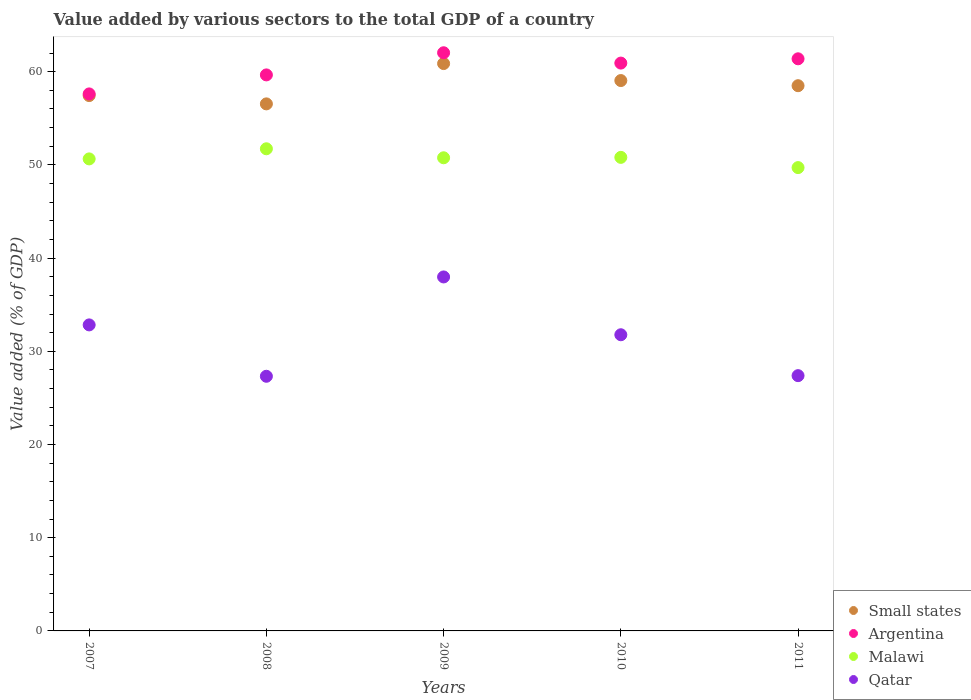How many different coloured dotlines are there?
Your answer should be compact. 4. What is the value added by various sectors to the total GDP in Qatar in 2010?
Ensure brevity in your answer.  31.78. Across all years, what is the maximum value added by various sectors to the total GDP in Argentina?
Your response must be concise. 62.03. Across all years, what is the minimum value added by various sectors to the total GDP in Argentina?
Provide a short and direct response. 57.61. In which year was the value added by various sectors to the total GDP in Malawi minimum?
Your answer should be compact. 2011. What is the total value added by various sectors to the total GDP in Argentina in the graph?
Keep it short and to the point. 301.6. What is the difference between the value added by various sectors to the total GDP in Malawi in 2009 and that in 2010?
Your answer should be compact. -0.04. What is the difference between the value added by various sectors to the total GDP in Qatar in 2011 and the value added by various sectors to the total GDP in Malawi in 2010?
Offer a very short reply. -23.42. What is the average value added by various sectors to the total GDP in Small states per year?
Keep it short and to the point. 58.48. In the year 2007, what is the difference between the value added by various sectors to the total GDP in Argentina and value added by various sectors to the total GDP in Small states?
Offer a very short reply. 0.18. In how many years, is the value added by various sectors to the total GDP in Qatar greater than 58 %?
Ensure brevity in your answer.  0. What is the ratio of the value added by various sectors to the total GDP in Malawi in 2007 to that in 2009?
Offer a terse response. 1. Is the difference between the value added by various sectors to the total GDP in Argentina in 2010 and 2011 greater than the difference between the value added by various sectors to the total GDP in Small states in 2010 and 2011?
Your answer should be very brief. No. What is the difference between the highest and the second highest value added by various sectors to the total GDP in Small states?
Keep it short and to the point. 1.82. What is the difference between the highest and the lowest value added by various sectors to the total GDP in Qatar?
Provide a succinct answer. 10.66. Is the sum of the value added by various sectors to the total GDP in Malawi in 2008 and 2010 greater than the maximum value added by various sectors to the total GDP in Argentina across all years?
Make the answer very short. Yes. Is the value added by various sectors to the total GDP in Malawi strictly greater than the value added by various sectors to the total GDP in Qatar over the years?
Ensure brevity in your answer.  Yes. How many years are there in the graph?
Your response must be concise. 5. What is the difference between two consecutive major ticks on the Y-axis?
Make the answer very short. 10. Does the graph contain any zero values?
Your response must be concise. No. Where does the legend appear in the graph?
Ensure brevity in your answer.  Bottom right. How are the legend labels stacked?
Ensure brevity in your answer.  Vertical. What is the title of the graph?
Your response must be concise. Value added by various sectors to the total GDP of a country. Does "Equatorial Guinea" appear as one of the legend labels in the graph?
Provide a short and direct response. No. What is the label or title of the X-axis?
Your response must be concise. Years. What is the label or title of the Y-axis?
Offer a very short reply. Value added (% of GDP). What is the Value added (% of GDP) in Small states in 2007?
Your answer should be compact. 57.43. What is the Value added (% of GDP) of Argentina in 2007?
Ensure brevity in your answer.  57.61. What is the Value added (% of GDP) in Malawi in 2007?
Keep it short and to the point. 50.64. What is the Value added (% of GDP) of Qatar in 2007?
Provide a succinct answer. 32.83. What is the Value added (% of GDP) of Small states in 2008?
Provide a succinct answer. 56.54. What is the Value added (% of GDP) of Argentina in 2008?
Keep it short and to the point. 59.65. What is the Value added (% of GDP) in Malawi in 2008?
Offer a very short reply. 51.73. What is the Value added (% of GDP) in Qatar in 2008?
Offer a terse response. 27.32. What is the Value added (% of GDP) in Small states in 2009?
Ensure brevity in your answer.  60.87. What is the Value added (% of GDP) of Argentina in 2009?
Give a very brief answer. 62.03. What is the Value added (% of GDP) in Malawi in 2009?
Offer a very short reply. 50.76. What is the Value added (% of GDP) of Qatar in 2009?
Provide a short and direct response. 37.98. What is the Value added (% of GDP) in Small states in 2010?
Make the answer very short. 59.05. What is the Value added (% of GDP) of Argentina in 2010?
Your response must be concise. 60.92. What is the Value added (% of GDP) of Malawi in 2010?
Give a very brief answer. 50.81. What is the Value added (% of GDP) of Qatar in 2010?
Make the answer very short. 31.78. What is the Value added (% of GDP) of Small states in 2011?
Your answer should be compact. 58.49. What is the Value added (% of GDP) in Argentina in 2011?
Make the answer very short. 61.38. What is the Value added (% of GDP) of Malawi in 2011?
Give a very brief answer. 49.71. What is the Value added (% of GDP) of Qatar in 2011?
Your answer should be compact. 27.39. Across all years, what is the maximum Value added (% of GDP) in Small states?
Give a very brief answer. 60.87. Across all years, what is the maximum Value added (% of GDP) of Argentina?
Offer a very short reply. 62.03. Across all years, what is the maximum Value added (% of GDP) of Malawi?
Make the answer very short. 51.73. Across all years, what is the maximum Value added (% of GDP) of Qatar?
Offer a very short reply. 37.98. Across all years, what is the minimum Value added (% of GDP) of Small states?
Give a very brief answer. 56.54. Across all years, what is the minimum Value added (% of GDP) in Argentina?
Your response must be concise. 57.61. Across all years, what is the minimum Value added (% of GDP) in Malawi?
Provide a short and direct response. 49.71. Across all years, what is the minimum Value added (% of GDP) of Qatar?
Your answer should be compact. 27.32. What is the total Value added (% of GDP) in Small states in the graph?
Keep it short and to the point. 292.39. What is the total Value added (% of GDP) of Argentina in the graph?
Make the answer very short. 301.6. What is the total Value added (% of GDP) of Malawi in the graph?
Ensure brevity in your answer.  253.64. What is the total Value added (% of GDP) of Qatar in the graph?
Provide a short and direct response. 157.29. What is the difference between the Value added (% of GDP) of Small states in 2007 and that in 2008?
Make the answer very short. 0.89. What is the difference between the Value added (% of GDP) in Argentina in 2007 and that in 2008?
Make the answer very short. -2.04. What is the difference between the Value added (% of GDP) in Malawi in 2007 and that in 2008?
Your response must be concise. -1.09. What is the difference between the Value added (% of GDP) in Qatar in 2007 and that in 2008?
Offer a terse response. 5.51. What is the difference between the Value added (% of GDP) in Small states in 2007 and that in 2009?
Keep it short and to the point. -3.44. What is the difference between the Value added (% of GDP) in Argentina in 2007 and that in 2009?
Your answer should be compact. -4.42. What is the difference between the Value added (% of GDP) of Malawi in 2007 and that in 2009?
Your answer should be very brief. -0.12. What is the difference between the Value added (% of GDP) of Qatar in 2007 and that in 2009?
Give a very brief answer. -5.14. What is the difference between the Value added (% of GDP) in Small states in 2007 and that in 2010?
Ensure brevity in your answer.  -1.61. What is the difference between the Value added (% of GDP) of Argentina in 2007 and that in 2010?
Provide a short and direct response. -3.31. What is the difference between the Value added (% of GDP) of Malawi in 2007 and that in 2010?
Make the answer very short. -0.16. What is the difference between the Value added (% of GDP) of Qatar in 2007 and that in 2010?
Provide a succinct answer. 1.06. What is the difference between the Value added (% of GDP) in Small states in 2007 and that in 2011?
Keep it short and to the point. -1.06. What is the difference between the Value added (% of GDP) of Argentina in 2007 and that in 2011?
Keep it short and to the point. -3.77. What is the difference between the Value added (% of GDP) in Malawi in 2007 and that in 2011?
Your answer should be very brief. 0.93. What is the difference between the Value added (% of GDP) in Qatar in 2007 and that in 2011?
Provide a succinct answer. 5.45. What is the difference between the Value added (% of GDP) of Small states in 2008 and that in 2009?
Make the answer very short. -4.33. What is the difference between the Value added (% of GDP) in Argentina in 2008 and that in 2009?
Your response must be concise. -2.38. What is the difference between the Value added (% of GDP) in Malawi in 2008 and that in 2009?
Ensure brevity in your answer.  0.97. What is the difference between the Value added (% of GDP) of Qatar in 2008 and that in 2009?
Make the answer very short. -10.66. What is the difference between the Value added (% of GDP) of Small states in 2008 and that in 2010?
Offer a terse response. -2.5. What is the difference between the Value added (% of GDP) of Argentina in 2008 and that in 2010?
Provide a short and direct response. -1.27. What is the difference between the Value added (% of GDP) in Malawi in 2008 and that in 2010?
Your answer should be very brief. 0.92. What is the difference between the Value added (% of GDP) in Qatar in 2008 and that in 2010?
Keep it short and to the point. -4.45. What is the difference between the Value added (% of GDP) of Small states in 2008 and that in 2011?
Make the answer very short. -1.95. What is the difference between the Value added (% of GDP) in Argentina in 2008 and that in 2011?
Offer a terse response. -1.73. What is the difference between the Value added (% of GDP) in Malawi in 2008 and that in 2011?
Keep it short and to the point. 2.02. What is the difference between the Value added (% of GDP) of Qatar in 2008 and that in 2011?
Give a very brief answer. -0.07. What is the difference between the Value added (% of GDP) in Small states in 2009 and that in 2010?
Ensure brevity in your answer.  1.82. What is the difference between the Value added (% of GDP) of Argentina in 2009 and that in 2010?
Offer a terse response. 1.11. What is the difference between the Value added (% of GDP) of Malawi in 2009 and that in 2010?
Provide a succinct answer. -0.04. What is the difference between the Value added (% of GDP) in Qatar in 2009 and that in 2010?
Offer a very short reply. 6.2. What is the difference between the Value added (% of GDP) of Small states in 2009 and that in 2011?
Give a very brief answer. 2.38. What is the difference between the Value added (% of GDP) in Argentina in 2009 and that in 2011?
Offer a terse response. 0.65. What is the difference between the Value added (% of GDP) in Malawi in 2009 and that in 2011?
Make the answer very short. 1.05. What is the difference between the Value added (% of GDP) of Qatar in 2009 and that in 2011?
Provide a succinct answer. 10.59. What is the difference between the Value added (% of GDP) of Small states in 2010 and that in 2011?
Ensure brevity in your answer.  0.55. What is the difference between the Value added (% of GDP) of Argentina in 2010 and that in 2011?
Keep it short and to the point. -0.46. What is the difference between the Value added (% of GDP) of Malawi in 2010 and that in 2011?
Offer a terse response. 1.1. What is the difference between the Value added (% of GDP) in Qatar in 2010 and that in 2011?
Provide a short and direct response. 4.39. What is the difference between the Value added (% of GDP) in Small states in 2007 and the Value added (% of GDP) in Argentina in 2008?
Your response must be concise. -2.22. What is the difference between the Value added (% of GDP) in Small states in 2007 and the Value added (% of GDP) in Malawi in 2008?
Ensure brevity in your answer.  5.71. What is the difference between the Value added (% of GDP) of Small states in 2007 and the Value added (% of GDP) of Qatar in 2008?
Keep it short and to the point. 30.11. What is the difference between the Value added (% of GDP) of Argentina in 2007 and the Value added (% of GDP) of Malawi in 2008?
Give a very brief answer. 5.89. What is the difference between the Value added (% of GDP) of Argentina in 2007 and the Value added (% of GDP) of Qatar in 2008?
Your answer should be compact. 30.29. What is the difference between the Value added (% of GDP) of Malawi in 2007 and the Value added (% of GDP) of Qatar in 2008?
Your answer should be compact. 23.32. What is the difference between the Value added (% of GDP) of Small states in 2007 and the Value added (% of GDP) of Argentina in 2009?
Give a very brief answer. -4.6. What is the difference between the Value added (% of GDP) in Small states in 2007 and the Value added (% of GDP) in Malawi in 2009?
Offer a very short reply. 6.67. What is the difference between the Value added (% of GDP) of Small states in 2007 and the Value added (% of GDP) of Qatar in 2009?
Your answer should be very brief. 19.46. What is the difference between the Value added (% of GDP) of Argentina in 2007 and the Value added (% of GDP) of Malawi in 2009?
Give a very brief answer. 6.85. What is the difference between the Value added (% of GDP) of Argentina in 2007 and the Value added (% of GDP) of Qatar in 2009?
Make the answer very short. 19.64. What is the difference between the Value added (% of GDP) in Malawi in 2007 and the Value added (% of GDP) in Qatar in 2009?
Provide a succinct answer. 12.66. What is the difference between the Value added (% of GDP) of Small states in 2007 and the Value added (% of GDP) of Argentina in 2010?
Your answer should be very brief. -3.49. What is the difference between the Value added (% of GDP) in Small states in 2007 and the Value added (% of GDP) in Malawi in 2010?
Give a very brief answer. 6.63. What is the difference between the Value added (% of GDP) of Small states in 2007 and the Value added (% of GDP) of Qatar in 2010?
Ensure brevity in your answer.  25.66. What is the difference between the Value added (% of GDP) in Argentina in 2007 and the Value added (% of GDP) in Malawi in 2010?
Your answer should be very brief. 6.81. What is the difference between the Value added (% of GDP) in Argentina in 2007 and the Value added (% of GDP) in Qatar in 2010?
Give a very brief answer. 25.84. What is the difference between the Value added (% of GDP) in Malawi in 2007 and the Value added (% of GDP) in Qatar in 2010?
Offer a terse response. 18.87. What is the difference between the Value added (% of GDP) in Small states in 2007 and the Value added (% of GDP) in Argentina in 2011?
Give a very brief answer. -3.95. What is the difference between the Value added (% of GDP) of Small states in 2007 and the Value added (% of GDP) of Malawi in 2011?
Provide a succinct answer. 7.73. What is the difference between the Value added (% of GDP) in Small states in 2007 and the Value added (% of GDP) in Qatar in 2011?
Offer a very short reply. 30.05. What is the difference between the Value added (% of GDP) of Argentina in 2007 and the Value added (% of GDP) of Malawi in 2011?
Provide a short and direct response. 7.9. What is the difference between the Value added (% of GDP) of Argentina in 2007 and the Value added (% of GDP) of Qatar in 2011?
Ensure brevity in your answer.  30.23. What is the difference between the Value added (% of GDP) of Malawi in 2007 and the Value added (% of GDP) of Qatar in 2011?
Offer a terse response. 23.25. What is the difference between the Value added (% of GDP) of Small states in 2008 and the Value added (% of GDP) of Argentina in 2009?
Offer a very short reply. -5.49. What is the difference between the Value added (% of GDP) of Small states in 2008 and the Value added (% of GDP) of Malawi in 2009?
Your answer should be compact. 5.78. What is the difference between the Value added (% of GDP) in Small states in 2008 and the Value added (% of GDP) in Qatar in 2009?
Your response must be concise. 18.57. What is the difference between the Value added (% of GDP) in Argentina in 2008 and the Value added (% of GDP) in Malawi in 2009?
Your response must be concise. 8.89. What is the difference between the Value added (% of GDP) of Argentina in 2008 and the Value added (% of GDP) of Qatar in 2009?
Offer a terse response. 21.68. What is the difference between the Value added (% of GDP) of Malawi in 2008 and the Value added (% of GDP) of Qatar in 2009?
Offer a terse response. 13.75. What is the difference between the Value added (% of GDP) in Small states in 2008 and the Value added (% of GDP) in Argentina in 2010?
Provide a succinct answer. -4.38. What is the difference between the Value added (% of GDP) in Small states in 2008 and the Value added (% of GDP) in Malawi in 2010?
Give a very brief answer. 5.74. What is the difference between the Value added (% of GDP) in Small states in 2008 and the Value added (% of GDP) in Qatar in 2010?
Your response must be concise. 24.77. What is the difference between the Value added (% of GDP) in Argentina in 2008 and the Value added (% of GDP) in Malawi in 2010?
Your answer should be compact. 8.85. What is the difference between the Value added (% of GDP) of Argentina in 2008 and the Value added (% of GDP) of Qatar in 2010?
Keep it short and to the point. 27.88. What is the difference between the Value added (% of GDP) in Malawi in 2008 and the Value added (% of GDP) in Qatar in 2010?
Your response must be concise. 19.95. What is the difference between the Value added (% of GDP) of Small states in 2008 and the Value added (% of GDP) of Argentina in 2011?
Make the answer very short. -4.84. What is the difference between the Value added (% of GDP) in Small states in 2008 and the Value added (% of GDP) in Malawi in 2011?
Keep it short and to the point. 6.84. What is the difference between the Value added (% of GDP) in Small states in 2008 and the Value added (% of GDP) in Qatar in 2011?
Your response must be concise. 29.16. What is the difference between the Value added (% of GDP) of Argentina in 2008 and the Value added (% of GDP) of Malawi in 2011?
Keep it short and to the point. 9.94. What is the difference between the Value added (% of GDP) in Argentina in 2008 and the Value added (% of GDP) in Qatar in 2011?
Offer a very short reply. 32.27. What is the difference between the Value added (% of GDP) in Malawi in 2008 and the Value added (% of GDP) in Qatar in 2011?
Keep it short and to the point. 24.34. What is the difference between the Value added (% of GDP) of Small states in 2009 and the Value added (% of GDP) of Argentina in 2010?
Offer a very short reply. -0.05. What is the difference between the Value added (% of GDP) of Small states in 2009 and the Value added (% of GDP) of Malawi in 2010?
Your response must be concise. 10.06. What is the difference between the Value added (% of GDP) in Small states in 2009 and the Value added (% of GDP) in Qatar in 2010?
Give a very brief answer. 29.09. What is the difference between the Value added (% of GDP) of Argentina in 2009 and the Value added (% of GDP) of Malawi in 2010?
Give a very brief answer. 11.22. What is the difference between the Value added (% of GDP) in Argentina in 2009 and the Value added (% of GDP) in Qatar in 2010?
Offer a very short reply. 30.25. What is the difference between the Value added (% of GDP) in Malawi in 2009 and the Value added (% of GDP) in Qatar in 2010?
Make the answer very short. 18.99. What is the difference between the Value added (% of GDP) in Small states in 2009 and the Value added (% of GDP) in Argentina in 2011?
Your response must be concise. -0.51. What is the difference between the Value added (% of GDP) of Small states in 2009 and the Value added (% of GDP) of Malawi in 2011?
Offer a very short reply. 11.16. What is the difference between the Value added (% of GDP) in Small states in 2009 and the Value added (% of GDP) in Qatar in 2011?
Make the answer very short. 33.48. What is the difference between the Value added (% of GDP) of Argentina in 2009 and the Value added (% of GDP) of Malawi in 2011?
Provide a short and direct response. 12.32. What is the difference between the Value added (% of GDP) of Argentina in 2009 and the Value added (% of GDP) of Qatar in 2011?
Provide a short and direct response. 34.64. What is the difference between the Value added (% of GDP) of Malawi in 2009 and the Value added (% of GDP) of Qatar in 2011?
Your response must be concise. 23.37. What is the difference between the Value added (% of GDP) of Small states in 2010 and the Value added (% of GDP) of Argentina in 2011?
Keep it short and to the point. -2.33. What is the difference between the Value added (% of GDP) in Small states in 2010 and the Value added (% of GDP) in Malawi in 2011?
Give a very brief answer. 9.34. What is the difference between the Value added (% of GDP) in Small states in 2010 and the Value added (% of GDP) in Qatar in 2011?
Your answer should be very brief. 31.66. What is the difference between the Value added (% of GDP) of Argentina in 2010 and the Value added (% of GDP) of Malawi in 2011?
Your answer should be very brief. 11.21. What is the difference between the Value added (% of GDP) in Argentina in 2010 and the Value added (% of GDP) in Qatar in 2011?
Provide a short and direct response. 33.53. What is the difference between the Value added (% of GDP) in Malawi in 2010 and the Value added (% of GDP) in Qatar in 2011?
Provide a short and direct response. 23.42. What is the average Value added (% of GDP) of Small states per year?
Keep it short and to the point. 58.48. What is the average Value added (% of GDP) of Argentina per year?
Provide a short and direct response. 60.32. What is the average Value added (% of GDP) in Malawi per year?
Your answer should be compact. 50.73. What is the average Value added (% of GDP) in Qatar per year?
Provide a succinct answer. 31.46. In the year 2007, what is the difference between the Value added (% of GDP) in Small states and Value added (% of GDP) in Argentina?
Your answer should be compact. -0.18. In the year 2007, what is the difference between the Value added (% of GDP) of Small states and Value added (% of GDP) of Malawi?
Ensure brevity in your answer.  6.79. In the year 2007, what is the difference between the Value added (% of GDP) in Small states and Value added (% of GDP) in Qatar?
Your response must be concise. 24.6. In the year 2007, what is the difference between the Value added (% of GDP) in Argentina and Value added (% of GDP) in Malawi?
Provide a short and direct response. 6.97. In the year 2007, what is the difference between the Value added (% of GDP) in Argentina and Value added (% of GDP) in Qatar?
Keep it short and to the point. 24.78. In the year 2007, what is the difference between the Value added (% of GDP) in Malawi and Value added (% of GDP) in Qatar?
Your answer should be very brief. 17.81. In the year 2008, what is the difference between the Value added (% of GDP) of Small states and Value added (% of GDP) of Argentina?
Ensure brevity in your answer.  -3.11. In the year 2008, what is the difference between the Value added (% of GDP) of Small states and Value added (% of GDP) of Malawi?
Your answer should be very brief. 4.82. In the year 2008, what is the difference between the Value added (% of GDP) in Small states and Value added (% of GDP) in Qatar?
Provide a succinct answer. 29.22. In the year 2008, what is the difference between the Value added (% of GDP) in Argentina and Value added (% of GDP) in Malawi?
Offer a very short reply. 7.93. In the year 2008, what is the difference between the Value added (% of GDP) of Argentina and Value added (% of GDP) of Qatar?
Provide a short and direct response. 32.33. In the year 2008, what is the difference between the Value added (% of GDP) in Malawi and Value added (% of GDP) in Qatar?
Your answer should be very brief. 24.41. In the year 2009, what is the difference between the Value added (% of GDP) of Small states and Value added (% of GDP) of Argentina?
Offer a terse response. -1.16. In the year 2009, what is the difference between the Value added (% of GDP) in Small states and Value added (% of GDP) in Malawi?
Your answer should be compact. 10.11. In the year 2009, what is the difference between the Value added (% of GDP) of Small states and Value added (% of GDP) of Qatar?
Make the answer very short. 22.89. In the year 2009, what is the difference between the Value added (% of GDP) of Argentina and Value added (% of GDP) of Malawi?
Give a very brief answer. 11.27. In the year 2009, what is the difference between the Value added (% of GDP) in Argentina and Value added (% of GDP) in Qatar?
Your answer should be compact. 24.05. In the year 2009, what is the difference between the Value added (% of GDP) in Malawi and Value added (% of GDP) in Qatar?
Your response must be concise. 12.78. In the year 2010, what is the difference between the Value added (% of GDP) of Small states and Value added (% of GDP) of Argentina?
Make the answer very short. -1.87. In the year 2010, what is the difference between the Value added (% of GDP) of Small states and Value added (% of GDP) of Malawi?
Your answer should be compact. 8.24. In the year 2010, what is the difference between the Value added (% of GDP) of Small states and Value added (% of GDP) of Qatar?
Offer a terse response. 27.27. In the year 2010, what is the difference between the Value added (% of GDP) in Argentina and Value added (% of GDP) in Malawi?
Your response must be concise. 10.11. In the year 2010, what is the difference between the Value added (% of GDP) in Argentina and Value added (% of GDP) in Qatar?
Ensure brevity in your answer.  29.15. In the year 2010, what is the difference between the Value added (% of GDP) of Malawi and Value added (% of GDP) of Qatar?
Offer a very short reply. 19.03. In the year 2011, what is the difference between the Value added (% of GDP) of Small states and Value added (% of GDP) of Argentina?
Keep it short and to the point. -2.88. In the year 2011, what is the difference between the Value added (% of GDP) in Small states and Value added (% of GDP) in Malawi?
Your answer should be very brief. 8.79. In the year 2011, what is the difference between the Value added (% of GDP) of Small states and Value added (% of GDP) of Qatar?
Offer a very short reply. 31.11. In the year 2011, what is the difference between the Value added (% of GDP) of Argentina and Value added (% of GDP) of Malawi?
Your response must be concise. 11.67. In the year 2011, what is the difference between the Value added (% of GDP) of Argentina and Value added (% of GDP) of Qatar?
Your answer should be very brief. 33.99. In the year 2011, what is the difference between the Value added (% of GDP) in Malawi and Value added (% of GDP) in Qatar?
Ensure brevity in your answer.  22.32. What is the ratio of the Value added (% of GDP) in Small states in 2007 to that in 2008?
Your answer should be compact. 1.02. What is the ratio of the Value added (% of GDP) of Argentina in 2007 to that in 2008?
Provide a succinct answer. 0.97. What is the ratio of the Value added (% of GDP) in Qatar in 2007 to that in 2008?
Provide a short and direct response. 1.2. What is the ratio of the Value added (% of GDP) of Small states in 2007 to that in 2009?
Your answer should be very brief. 0.94. What is the ratio of the Value added (% of GDP) of Argentina in 2007 to that in 2009?
Make the answer very short. 0.93. What is the ratio of the Value added (% of GDP) in Malawi in 2007 to that in 2009?
Your answer should be compact. 1. What is the ratio of the Value added (% of GDP) of Qatar in 2007 to that in 2009?
Offer a very short reply. 0.86. What is the ratio of the Value added (% of GDP) in Small states in 2007 to that in 2010?
Give a very brief answer. 0.97. What is the ratio of the Value added (% of GDP) of Argentina in 2007 to that in 2010?
Provide a short and direct response. 0.95. What is the ratio of the Value added (% of GDP) in Small states in 2007 to that in 2011?
Provide a succinct answer. 0.98. What is the ratio of the Value added (% of GDP) in Argentina in 2007 to that in 2011?
Provide a short and direct response. 0.94. What is the ratio of the Value added (% of GDP) in Malawi in 2007 to that in 2011?
Provide a short and direct response. 1.02. What is the ratio of the Value added (% of GDP) in Qatar in 2007 to that in 2011?
Provide a short and direct response. 1.2. What is the ratio of the Value added (% of GDP) in Small states in 2008 to that in 2009?
Your answer should be very brief. 0.93. What is the ratio of the Value added (% of GDP) of Argentina in 2008 to that in 2009?
Give a very brief answer. 0.96. What is the ratio of the Value added (% of GDP) of Qatar in 2008 to that in 2009?
Your response must be concise. 0.72. What is the ratio of the Value added (% of GDP) of Small states in 2008 to that in 2010?
Your answer should be compact. 0.96. What is the ratio of the Value added (% of GDP) in Argentina in 2008 to that in 2010?
Ensure brevity in your answer.  0.98. What is the ratio of the Value added (% of GDP) of Malawi in 2008 to that in 2010?
Keep it short and to the point. 1.02. What is the ratio of the Value added (% of GDP) of Qatar in 2008 to that in 2010?
Your answer should be compact. 0.86. What is the ratio of the Value added (% of GDP) in Small states in 2008 to that in 2011?
Your response must be concise. 0.97. What is the ratio of the Value added (% of GDP) of Argentina in 2008 to that in 2011?
Provide a succinct answer. 0.97. What is the ratio of the Value added (% of GDP) in Malawi in 2008 to that in 2011?
Your answer should be very brief. 1.04. What is the ratio of the Value added (% of GDP) in Qatar in 2008 to that in 2011?
Offer a very short reply. 1. What is the ratio of the Value added (% of GDP) in Small states in 2009 to that in 2010?
Your answer should be very brief. 1.03. What is the ratio of the Value added (% of GDP) of Argentina in 2009 to that in 2010?
Offer a terse response. 1.02. What is the ratio of the Value added (% of GDP) in Qatar in 2009 to that in 2010?
Your response must be concise. 1.2. What is the ratio of the Value added (% of GDP) in Small states in 2009 to that in 2011?
Offer a very short reply. 1.04. What is the ratio of the Value added (% of GDP) of Argentina in 2009 to that in 2011?
Provide a succinct answer. 1.01. What is the ratio of the Value added (% of GDP) in Malawi in 2009 to that in 2011?
Your answer should be compact. 1.02. What is the ratio of the Value added (% of GDP) in Qatar in 2009 to that in 2011?
Keep it short and to the point. 1.39. What is the ratio of the Value added (% of GDP) in Small states in 2010 to that in 2011?
Provide a succinct answer. 1.01. What is the ratio of the Value added (% of GDP) in Argentina in 2010 to that in 2011?
Offer a very short reply. 0.99. What is the ratio of the Value added (% of GDP) of Malawi in 2010 to that in 2011?
Your answer should be compact. 1.02. What is the ratio of the Value added (% of GDP) of Qatar in 2010 to that in 2011?
Provide a short and direct response. 1.16. What is the difference between the highest and the second highest Value added (% of GDP) in Small states?
Provide a short and direct response. 1.82. What is the difference between the highest and the second highest Value added (% of GDP) in Argentina?
Give a very brief answer. 0.65. What is the difference between the highest and the second highest Value added (% of GDP) in Malawi?
Offer a terse response. 0.92. What is the difference between the highest and the second highest Value added (% of GDP) of Qatar?
Ensure brevity in your answer.  5.14. What is the difference between the highest and the lowest Value added (% of GDP) of Small states?
Your answer should be compact. 4.33. What is the difference between the highest and the lowest Value added (% of GDP) in Argentina?
Your answer should be compact. 4.42. What is the difference between the highest and the lowest Value added (% of GDP) in Malawi?
Offer a terse response. 2.02. What is the difference between the highest and the lowest Value added (% of GDP) of Qatar?
Offer a very short reply. 10.66. 